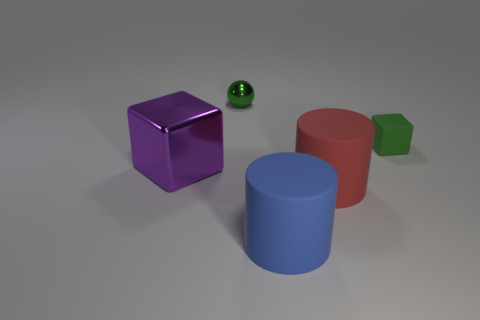How many matte blocks are the same color as the small shiny ball?
Your response must be concise. 1. What number of spheres are big purple objects or small green matte objects?
Offer a terse response. 0. What is the color of the block that is the same size as the green sphere?
Ensure brevity in your answer.  Green. There is a rubber thing that is behind the big object to the left of the shiny ball; is there a matte object to the left of it?
Offer a very short reply. Yes. What size is the rubber block?
Provide a succinct answer. Small. What number of objects are blue objects or brown blocks?
Give a very brief answer. 1. The tiny ball that is made of the same material as the purple object is what color?
Offer a very short reply. Green. There is a green object behind the green rubber object; does it have the same shape as the large blue rubber object?
Keep it short and to the point. No. What number of things are shiny things that are behind the green matte block or large objects that are in front of the red rubber cylinder?
Offer a very short reply. 2. There is another thing that is the same shape as the large red thing; what color is it?
Offer a very short reply. Blue. 